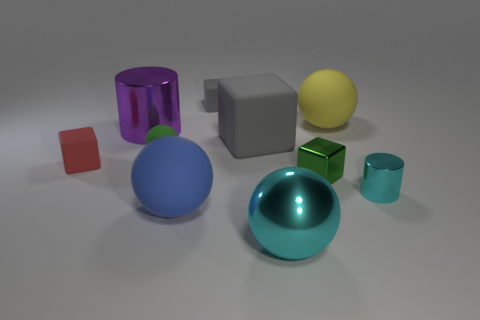Subtract all small spheres. How many spheres are left? 3 Subtract all red balls. How many gray blocks are left? 2 Subtract all balls. How many objects are left? 6 Subtract 2 blocks. How many blocks are left? 2 Subtract all green cubes. How many cubes are left? 3 Subtract all yellow blocks. Subtract all yellow spheres. How many blocks are left? 4 Subtract all big yellow matte spheres. Subtract all cyan metallic spheres. How many objects are left? 8 Add 8 gray objects. How many gray objects are left? 10 Add 5 big purple objects. How many big purple objects exist? 6 Subtract 0 brown cylinders. How many objects are left? 10 